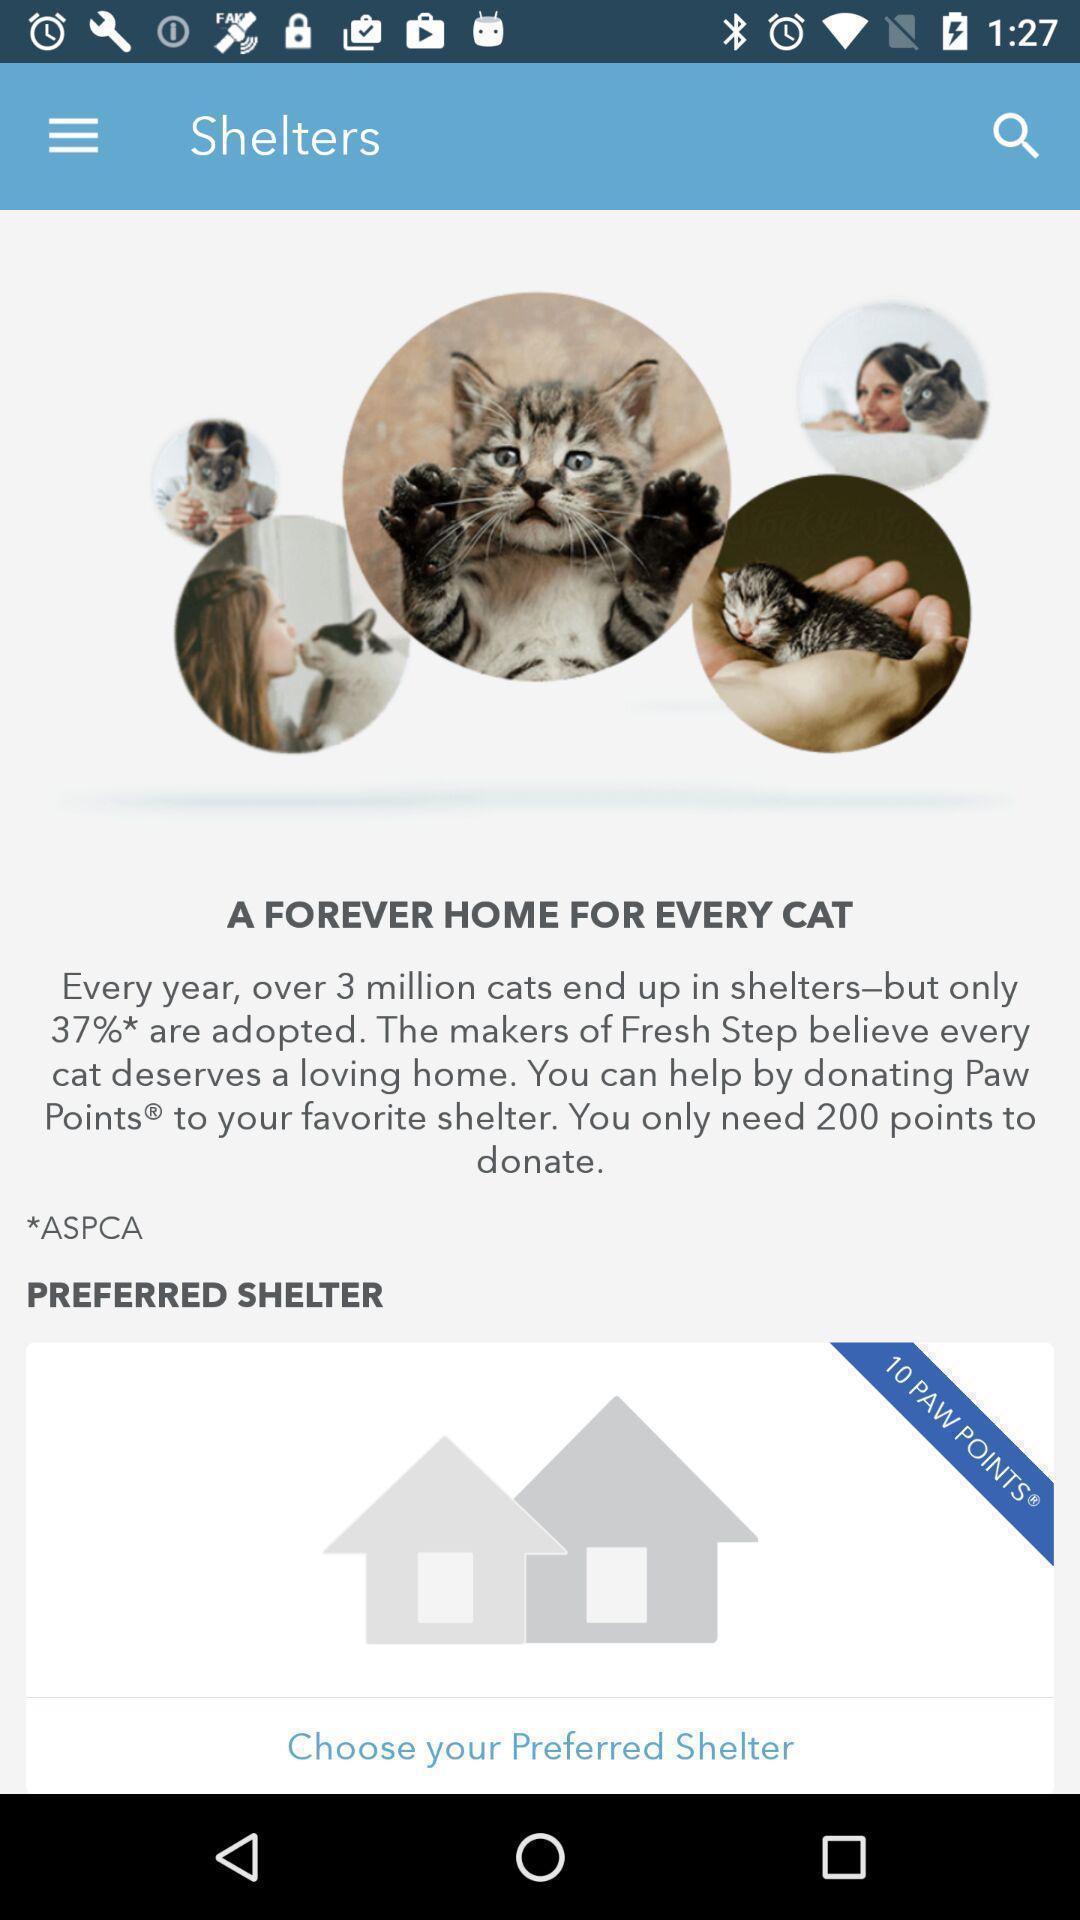Tell me about the visual elements in this screen capture. Screen shows about shelters app for cats. 